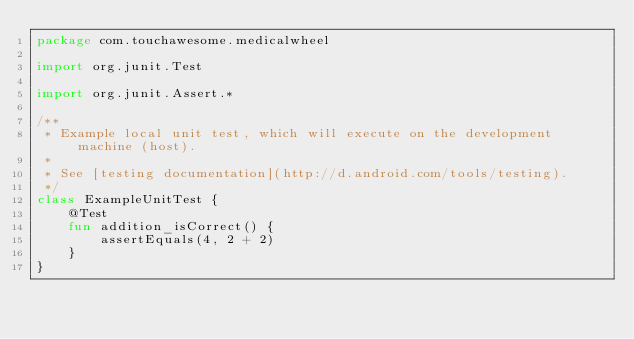<code> <loc_0><loc_0><loc_500><loc_500><_Kotlin_>package com.touchawesome.medicalwheel

import org.junit.Test

import org.junit.Assert.*

/**
 * Example local unit test, which will execute on the development machine (host).
 *
 * See [testing documentation](http://d.android.com/tools/testing).
 */
class ExampleUnitTest {
    @Test
    fun addition_isCorrect() {
        assertEquals(4, 2 + 2)
    }
}
</code> 